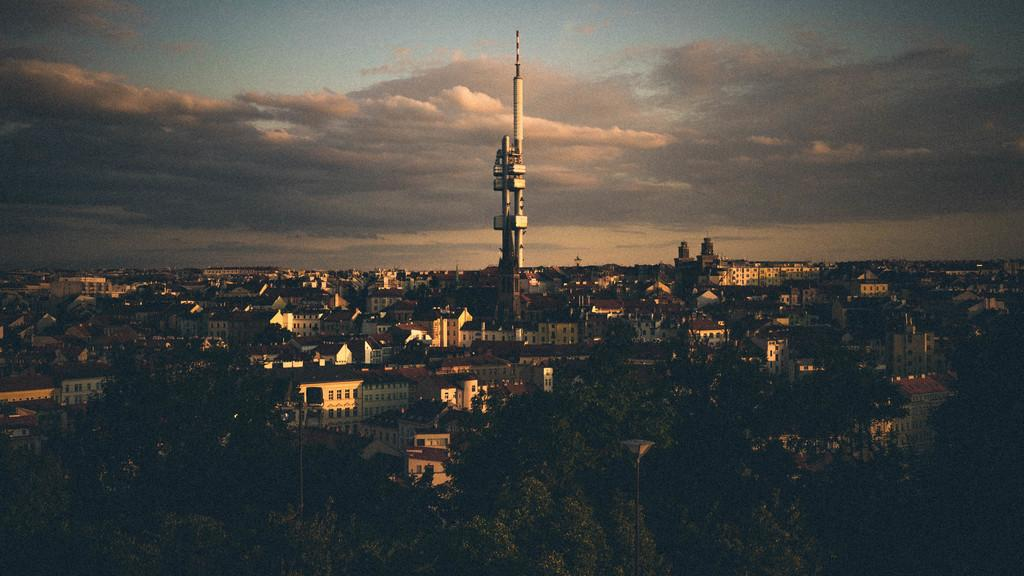What type of natural elements can be seen in the image? There are trees in the image. What type of man-made structures are present in the image? There are buildings and a tower in the image. What is the condition of the sky in the image? The sky is cloudy in the image. What month is it in the image? The month cannot be determined from the image, as there is no information about the date or time of year. Can you see a basketball court in the image? There is no basketball court present in the image. 